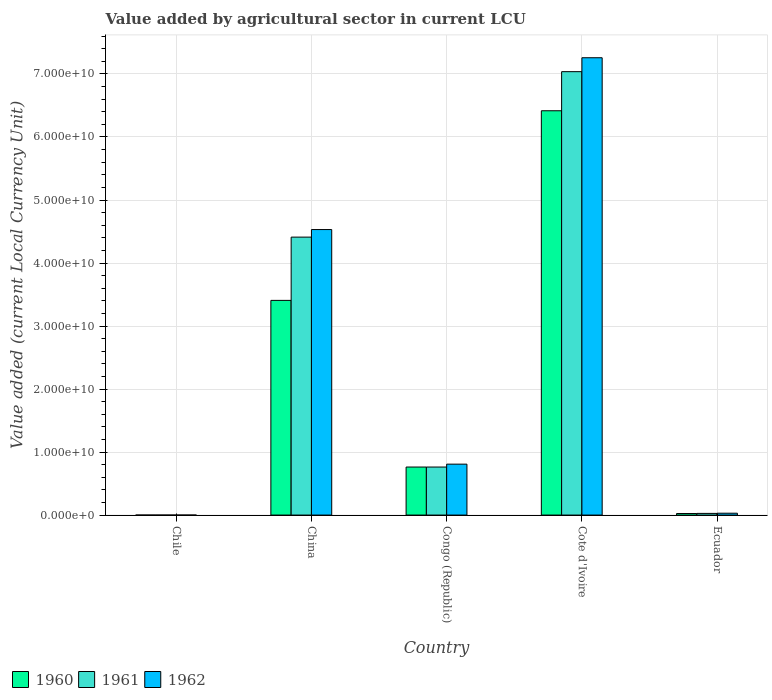How many different coloured bars are there?
Your answer should be compact. 3. How many groups of bars are there?
Provide a succinct answer. 5. How many bars are there on the 2nd tick from the right?
Your response must be concise. 3. What is the label of the 4th group of bars from the left?
Keep it short and to the point. Cote d'Ivoire. In how many cases, is the number of bars for a given country not equal to the number of legend labels?
Give a very brief answer. 0. What is the value added by agricultural sector in 1962 in China?
Your answer should be very brief. 4.53e+1. Across all countries, what is the maximum value added by agricultural sector in 1961?
Ensure brevity in your answer.  7.04e+1. In which country was the value added by agricultural sector in 1962 maximum?
Provide a succinct answer. Cote d'Ivoire. In which country was the value added by agricultural sector in 1962 minimum?
Ensure brevity in your answer.  Chile. What is the total value added by agricultural sector in 1960 in the graph?
Give a very brief answer. 1.06e+11. What is the difference between the value added by agricultural sector in 1960 in Chile and that in China?
Offer a very short reply. -3.41e+1. What is the difference between the value added by agricultural sector in 1962 in Chile and the value added by agricultural sector in 1960 in Congo (Republic)?
Your answer should be very brief. -7.62e+09. What is the average value added by agricultural sector in 1960 per country?
Make the answer very short. 2.12e+1. What is the difference between the value added by agricultural sector of/in 1960 and value added by agricultural sector of/in 1962 in Cote d'Ivoire?
Ensure brevity in your answer.  -8.41e+09. What is the ratio of the value added by agricultural sector in 1962 in Congo (Republic) to that in Ecuador?
Your response must be concise. 27.39. Is the value added by agricultural sector in 1961 in Chile less than that in China?
Give a very brief answer. Yes. Is the difference between the value added by agricultural sector in 1960 in China and Cote d'Ivoire greater than the difference between the value added by agricultural sector in 1962 in China and Cote d'Ivoire?
Provide a succinct answer. No. What is the difference between the highest and the second highest value added by agricultural sector in 1962?
Your answer should be compact. 6.45e+1. What is the difference between the highest and the lowest value added by agricultural sector in 1961?
Keep it short and to the point. 7.04e+1. What does the 3rd bar from the right in Congo (Republic) represents?
Ensure brevity in your answer.  1960. Are all the bars in the graph horizontal?
Offer a very short reply. No. How many countries are there in the graph?
Offer a terse response. 5. What is the difference between two consecutive major ticks on the Y-axis?
Give a very brief answer. 1.00e+1. Does the graph contain grids?
Ensure brevity in your answer.  Yes. How are the legend labels stacked?
Make the answer very short. Horizontal. What is the title of the graph?
Offer a very short reply. Value added by agricultural sector in current LCU. What is the label or title of the X-axis?
Your answer should be compact. Country. What is the label or title of the Y-axis?
Offer a very short reply. Value added (current Local Currency Unit). What is the Value added (current Local Currency Unit) of 1962 in Chile?
Make the answer very short. 5.00e+05. What is the Value added (current Local Currency Unit) of 1960 in China?
Keep it short and to the point. 3.41e+1. What is the Value added (current Local Currency Unit) in 1961 in China?
Provide a succinct answer. 4.41e+1. What is the Value added (current Local Currency Unit) of 1962 in China?
Your response must be concise. 4.53e+1. What is the Value added (current Local Currency Unit) in 1960 in Congo (Republic)?
Offer a terse response. 7.62e+09. What is the Value added (current Local Currency Unit) in 1961 in Congo (Republic)?
Keep it short and to the point. 7.62e+09. What is the Value added (current Local Currency Unit) in 1962 in Congo (Republic)?
Your answer should be compact. 8.08e+09. What is the Value added (current Local Currency Unit) of 1960 in Cote d'Ivoire?
Ensure brevity in your answer.  6.42e+1. What is the Value added (current Local Currency Unit) of 1961 in Cote d'Ivoire?
Make the answer very short. 7.04e+1. What is the Value added (current Local Currency Unit) of 1962 in Cote d'Ivoire?
Your answer should be very brief. 7.26e+1. What is the Value added (current Local Currency Unit) in 1960 in Ecuador?
Provide a short and direct response. 2.45e+08. What is the Value added (current Local Currency Unit) in 1961 in Ecuador?
Your response must be concise. 2.66e+08. What is the Value added (current Local Currency Unit) in 1962 in Ecuador?
Your answer should be compact. 2.95e+08. Across all countries, what is the maximum Value added (current Local Currency Unit) of 1960?
Make the answer very short. 6.42e+1. Across all countries, what is the maximum Value added (current Local Currency Unit) in 1961?
Offer a terse response. 7.04e+1. Across all countries, what is the maximum Value added (current Local Currency Unit) of 1962?
Make the answer very short. 7.26e+1. Across all countries, what is the minimum Value added (current Local Currency Unit) of 1961?
Provide a short and direct response. 5.00e+05. What is the total Value added (current Local Currency Unit) of 1960 in the graph?
Offer a terse response. 1.06e+11. What is the total Value added (current Local Currency Unit) of 1961 in the graph?
Offer a terse response. 1.22e+11. What is the total Value added (current Local Currency Unit) in 1962 in the graph?
Your response must be concise. 1.26e+11. What is the difference between the Value added (current Local Currency Unit) of 1960 in Chile and that in China?
Offer a very short reply. -3.41e+1. What is the difference between the Value added (current Local Currency Unit) in 1961 in Chile and that in China?
Ensure brevity in your answer.  -4.41e+1. What is the difference between the Value added (current Local Currency Unit) of 1962 in Chile and that in China?
Ensure brevity in your answer.  -4.53e+1. What is the difference between the Value added (current Local Currency Unit) in 1960 in Chile and that in Congo (Republic)?
Make the answer very short. -7.62e+09. What is the difference between the Value added (current Local Currency Unit) in 1961 in Chile and that in Congo (Republic)?
Your answer should be compact. -7.62e+09. What is the difference between the Value added (current Local Currency Unit) of 1962 in Chile and that in Congo (Republic)?
Provide a succinct answer. -8.08e+09. What is the difference between the Value added (current Local Currency Unit) in 1960 in Chile and that in Cote d'Ivoire?
Provide a short and direct response. -6.42e+1. What is the difference between the Value added (current Local Currency Unit) of 1961 in Chile and that in Cote d'Ivoire?
Your response must be concise. -7.04e+1. What is the difference between the Value added (current Local Currency Unit) of 1962 in Chile and that in Cote d'Ivoire?
Provide a succinct answer. -7.26e+1. What is the difference between the Value added (current Local Currency Unit) in 1960 in Chile and that in Ecuador?
Give a very brief answer. -2.45e+08. What is the difference between the Value added (current Local Currency Unit) in 1961 in Chile and that in Ecuador?
Ensure brevity in your answer.  -2.66e+08. What is the difference between the Value added (current Local Currency Unit) of 1962 in Chile and that in Ecuador?
Keep it short and to the point. -2.95e+08. What is the difference between the Value added (current Local Currency Unit) of 1960 in China and that in Congo (Republic)?
Make the answer very short. 2.64e+1. What is the difference between the Value added (current Local Currency Unit) of 1961 in China and that in Congo (Republic)?
Your answer should be very brief. 3.65e+1. What is the difference between the Value added (current Local Currency Unit) in 1962 in China and that in Congo (Republic)?
Provide a short and direct response. 3.72e+1. What is the difference between the Value added (current Local Currency Unit) in 1960 in China and that in Cote d'Ivoire?
Make the answer very short. -3.01e+1. What is the difference between the Value added (current Local Currency Unit) of 1961 in China and that in Cote d'Ivoire?
Keep it short and to the point. -2.63e+1. What is the difference between the Value added (current Local Currency Unit) of 1962 in China and that in Cote d'Ivoire?
Give a very brief answer. -2.73e+1. What is the difference between the Value added (current Local Currency Unit) in 1960 in China and that in Ecuador?
Offer a terse response. 3.38e+1. What is the difference between the Value added (current Local Currency Unit) in 1961 in China and that in Ecuador?
Offer a terse response. 4.38e+1. What is the difference between the Value added (current Local Currency Unit) of 1962 in China and that in Ecuador?
Your answer should be compact. 4.50e+1. What is the difference between the Value added (current Local Currency Unit) of 1960 in Congo (Republic) and that in Cote d'Ivoire?
Make the answer very short. -5.65e+1. What is the difference between the Value added (current Local Currency Unit) of 1961 in Congo (Republic) and that in Cote d'Ivoire?
Offer a terse response. -6.27e+1. What is the difference between the Value added (current Local Currency Unit) in 1962 in Congo (Republic) and that in Cote d'Ivoire?
Make the answer very short. -6.45e+1. What is the difference between the Value added (current Local Currency Unit) of 1960 in Congo (Republic) and that in Ecuador?
Your answer should be compact. 7.38e+09. What is the difference between the Value added (current Local Currency Unit) of 1961 in Congo (Republic) and that in Ecuador?
Give a very brief answer. 7.36e+09. What is the difference between the Value added (current Local Currency Unit) of 1962 in Congo (Republic) and that in Ecuador?
Your response must be concise. 7.79e+09. What is the difference between the Value added (current Local Currency Unit) of 1960 in Cote d'Ivoire and that in Ecuador?
Your answer should be compact. 6.39e+1. What is the difference between the Value added (current Local Currency Unit) of 1961 in Cote d'Ivoire and that in Ecuador?
Your answer should be compact. 7.01e+1. What is the difference between the Value added (current Local Currency Unit) in 1962 in Cote d'Ivoire and that in Ecuador?
Offer a very short reply. 7.23e+1. What is the difference between the Value added (current Local Currency Unit) of 1960 in Chile and the Value added (current Local Currency Unit) of 1961 in China?
Keep it short and to the point. -4.41e+1. What is the difference between the Value added (current Local Currency Unit) of 1960 in Chile and the Value added (current Local Currency Unit) of 1962 in China?
Your answer should be very brief. -4.53e+1. What is the difference between the Value added (current Local Currency Unit) of 1961 in Chile and the Value added (current Local Currency Unit) of 1962 in China?
Provide a short and direct response. -4.53e+1. What is the difference between the Value added (current Local Currency Unit) in 1960 in Chile and the Value added (current Local Currency Unit) in 1961 in Congo (Republic)?
Provide a short and direct response. -7.62e+09. What is the difference between the Value added (current Local Currency Unit) in 1960 in Chile and the Value added (current Local Currency Unit) in 1962 in Congo (Republic)?
Your response must be concise. -8.08e+09. What is the difference between the Value added (current Local Currency Unit) in 1961 in Chile and the Value added (current Local Currency Unit) in 1962 in Congo (Republic)?
Offer a very short reply. -8.08e+09. What is the difference between the Value added (current Local Currency Unit) in 1960 in Chile and the Value added (current Local Currency Unit) in 1961 in Cote d'Ivoire?
Offer a very short reply. -7.04e+1. What is the difference between the Value added (current Local Currency Unit) in 1960 in Chile and the Value added (current Local Currency Unit) in 1962 in Cote d'Ivoire?
Offer a terse response. -7.26e+1. What is the difference between the Value added (current Local Currency Unit) in 1961 in Chile and the Value added (current Local Currency Unit) in 1962 in Cote d'Ivoire?
Ensure brevity in your answer.  -7.26e+1. What is the difference between the Value added (current Local Currency Unit) in 1960 in Chile and the Value added (current Local Currency Unit) in 1961 in Ecuador?
Ensure brevity in your answer.  -2.66e+08. What is the difference between the Value added (current Local Currency Unit) of 1960 in Chile and the Value added (current Local Currency Unit) of 1962 in Ecuador?
Your response must be concise. -2.95e+08. What is the difference between the Value added (current Local Currency Unit) in 1961 in Chile and the Value added (current Local Currency Unit) in 1962 in Ecuador?
Provide a short and direct response. -2.95e+08. What is the difference between the Value added (current Local Currency Unit) in 1960 in China and the Value added (current Local Currency Unit) in 1961 in Congo (Republic)?
Ensure brevity in your answer.  2.64e+1. What is the difference between the Value added (current Local Currency Unit) in 1960 in China and the Value added (current Local Currency Unit) in 1962 in Congo (Republic)?
Ensure brevity in your answer.  2.60e+1. What is the difference between the Value added (current Local Currency Unit) in 1961 in China and the Value added (current Local Currency Unit) in 1962 in Congo (Republic)?
Make the answer very short. 3.60e+1. What is the difference between the Value added (current Local Currency Unit) in 1960 in China and the Value added (current Local Currency Unit) in 1961 in Cote d'Ivoire?
Offer a very short reply. -3.63e+1. What is the difference between the Value added (current Local Currency Unit) in 1960 in China and the Value added (current Local Currency Unit) in 1962 in Cote d'Ivoire?
Keep it short and to the point. -3.85e+1. What is the difference between the Value added (current Local Currency Unit) of 1961 in China and the Value added (current Local Currency Unit) of 1962 in Cote d'Ivoire?
Give a very brief answer. -2.85e+1. What is the difference between the Value added (current Local Currency Unit) in 1960 in China and the Value added (current Local Currency Unit) in 1961 in Ecuador?
Keep it short and to the point. 3.38e+1. What is the difference between the Value added (current Local Currency Unit) of 1960 in China and the Value added (current Local Currency Unit) of 1962 in Ecuador?
Give a very brief answer. 3.38e+1. What is the difference between the Value added (current Local Currency Unit) in 1961 in China and the Value added (current Local Currency Unit) in 1962 in Ecuador?
Provide a short and direct response. 4.38e+1. What is the difference between the Value added (current Local Currency Unit) of 1960 in Congo (Republic) and the Value added (current Local Currency Unit) of 1961 in Cote d'Ivoire?
Give a very brief answer. -6.27e+1. What is the difference between the Value added (current Local Currency Unit) of 1960 in Congo (Republic) and the Value added (current Local Currency Unit) of 1962 in Cote d'Ivoire?
Provide a short and direct response. -6.50e+1. What is the difference between the Value added (current Local Currency Unit) in 1961 in Congo (Republic) and the Value added (current Local Currency Unit) in 1962 in Cote d'Ivoire?
Your response must be concise. -6.50e+1. What is the difference between the Value added (current Local Currency Unit) in 1960 in Congo (Republic) and the Value added (current Local Currency Unit) in 1961 in Ecuador?
Keep it short and to the point. 7.36e+09. What is the difference between the Value added (current Local Currency Unit) in 1960 in Congo (Republic) and the Value added (current Local Currency Unit) in 1962 in Ecuador?
Offer a very short reply. 7.33e+09. What is the difference between the Value added (current Local Currency Unit) of 1961 in Congo (Republic) and the Value added (current Local Currency Unit) of 1962 in Ecuador?
Provide a succinct answer. 7.33e+09. What is the difference between the Value added (current Local Currency Unit) in 1960 in Cote d'Ivoire and the Value added (current Local Currency Unit) in 1961 in Ecuador?
Your answer should be compact. 6.39e+1. What is the difference between the Value added (current Local Currency Unit) of 1960 in Cote d'Ivoire and the Value added (current Local Currency Unit) of 1962 in Ecuador?
Provide a succinct answer. 6.39e+1. What is the difference between the Value added (current Local Currency Unit) in 1961 in Cote d'Ivoire and the Value added (current Local Currency Unit) in 1962 in Ecuador?
Make the answer very short. 7.01e+1. What is the average Value added (current Local Currency Unit) in 1960 per country?
Give a very brief answer. 2.12e+1. What is the average Value added (current Local Currency Unit) in 1961 per country?
Your response must be concise. 2.45e+1. What is the average Value added (current Local Currency Unit) in 1962 per country?
Your answer should be compact. 2.53e+1. What is the difference between the Value added (current Local Currency Unit) in 1960 and Value added (current Local Currency Unit) in 1961 in Chile?
Provide a succinct answer. -1.00e+05. What is the difference between the Value added (current Local Currency Unit) of 1960 and Value added (current Local Currency Unit) of 1962 in Chile?
Provide a succinct answer. -1.00e+05. What is the difference between the Value added (current Local Currency Unit) in 1961 and Value added (current Local Currency Unit) in 1962 in Chile?
Give a very brief answer. 0. What is the difference between the Value added (current Local Currency Unit) of 1960 and Value added (current Local Currency Unit) of 1961 in China?
Your answer should be compact. -1.00e+1. What is the difference between the Value added (current Local Currency Unit) in 1960 and Value added (current Local Currency Unit) in 1962 in China?
Offer a terse response. -1.12e+1. What is the difference between the Value added (current Local Currency Unit) of 1961 and Value added (current Local Currency Unit) of 1962 in China?
Ensure brevity in your answer.  -1.20e+09. What is the difference between the Value added (current Local Currency Unit) of 1960 and Value added (current Local Currency Unit) of 1961 in Congo (Republic)?
Your response must be concise. 0. What is the difference between the Value added (current Local Currency Unit) of 1960 and Value added (current Local Currency Unit) of 1962 in Congo (Republic)?
Keep it short and to the point. -4.57e+08. What is the difference between the Value added (current Local Currency Unit) of 1961 and Value added (current Local Currency Unit) of 1962 in Congo (Republic)?
Give a very brief answer. -4.57e+08. What is the difference between the Value added (current Local Currency Unit) of 1960 and Value added (current Local Currency Unit) of 1961 in Cote d'Ivoire?
Your answer should be very brief. -6.21e+09. What is the difference between the Value added (current Local Currency Unit) in 1960 and Value added (current Local Currency Unit) in 1962 in Cote d'Ivoire?
Provide a succinct answer. -8.41e+09. What is the difference between the Value added (current Local Currency Unit) in 1961 and Value added (current Local Currency Unit) in 1962 in Cote d'Ivoire?
Give a very brief answer. -2.21e+09. What is the difference between the Value added (current Local Currency Unit) of 1960 and Value added (current Local Currency Unit) of 1961 in Ecuador?
Offer a very short reply. -2.09e+07. What is the difference between the Value added (current Local Currency Unit) in 1960 and Value added (current Local Currency Unit) in 1962 in Ecuador?
Ensure brevity in your answer.  -4.98e+07. What is the difference between the Value added (current Local Currency Unit) in 1961 and Value added (current Local Currency Unit) in 1962 in Ecuador?
Give a very brief answer. -2.89e+07. What is the ratio of the Value added (current Local Currency Unit) in 1961 in Chile to that in Congo (Republic)?
Offer a terse response. 0. What is the ratio of the Value added (current Local Currency Unit) of 1960 in Chile to that in Cote d'Ivoire?
Keep it short and to the point. 0. What is the ratio of the Value added (current Local Currency Unit) of 1960 in Chile to that in Ecuador?
Your response must be concise. 0. What is the ratio of the Value added (current Local Currency Unit) of 1961 in Chile to that in Ecuador?
Keep it short and to the point. 0. What is the ratio of the Value added (current Local Currency Unit) in 1962 in Chile to that in Ecuador?
Offer a very short reply. 0. What is the ratio of the Value added (current Local Currency Unit) of 1960 in China to that in Congo (Republic)?
Give a very brief answer. 4.47. What is the ratio of the Value added (current Local Currency Unit) of 1961 in China to that in Congo (Republic)?
Provide a succinct answer. 5.79. What is the ratio of the Value added (current Local Currency Unit) of 1962 in China to that in Congo (Republic)?
Ensure brevity in your answer.  5.61. What is the ratio of the Value added (current Local Currency Unit) in 1960 in China to that in Cote d'Ivoire?
Ensure brevity in your answer.  0.53. What is the ratio of the Value added (current Local Currency Unit) of 1961 in China to that in Cote d'Ivoire?
Give a very brief answer. 0.63. What is the ratio of the Value added (current Local Currency Unit) in 1962 in China to that in Cote d'Ivoire?
Your answer should be very brief. 0.62. What is the ratio of the Value added (current Local Currency Unit) in 1960 in China to that in Ecuador?
Provide a short and direct response. 138.9. What is the ratio of the Value added (current Local Currency Unit) in 1961 in China to that in Ecuador?
Your answer should be compact. 165.71. What is the ratio of the Value added (current Local Currency Unit) in 1962 in China to that in Ecuador?
Keep it short and to the point. 153.57. What is the ratio of the Value added (current Local Currency Unit) of 1960 in Congo (Republic) to that in Cote d'Ivoire?
Make the answer very short. 0.12. What is the ratio of the Value added (current Local Currency Unit) of 1961 in Congo (Republic) to that in Cote d'Ivoire?
Offer a terse response. 0.11. What is the ratio of the Value added (current Local Currency Unit) of 1962 in Congo (Republic) to that in Cote d'Ivoire?
Ensure brevity in your answer.  0.11. What is the ratio of the Value added (current Local Currency Unit) of 1960 in Congo (Republic) to that in Ecuador?
Give a very brief answer. 31.08. What is the ratio of the Value added (current Local Currency Unit) of 1961 in Congo (Republic) to that in Ecuador?
Provide a short and direct response. 28.64. What is the ratio of the Value added (current Local Currency Unit) of 1962 in Congo (Republic) to that in Ecuador?
Give a very brief answer. 27.39. What is the ratio of the Value added (current Local Currency Unit) in 1960 in Cote d'Ivoire to that in Ecuador?
Keep it short and to the point. 261.58. What is the ratio of the Value added (current Local Currency Unit) in 1961 in Cote d'Ivoire to that in Ecuador?
Keep it short and to the point. 264.35. What is the ratio of the Value added (current Local Currency Unit) of 1962 in Cote d'Ivoire to that in Ecuador?
Provide a short and direct response. 245.99. What is the difference between the highest and the second highest Value added (current Local Currency Unit) in 1960?
Provide a short and direct response. 3.01e+1. What is the difference between the highest and the second highest Value added (current Local Currency Unit) of 1961?
Provide a succinct answer. 2.63e+1. What is the difference between the highest and the second highest Value added (current Local Currency Unit) of 1962?
Ensure brevity in your answer.  2.73e+1. What is the difference between the highest and the lowest Value added (current Local Currency Unit) in 1960?
Your answer should be compact. 6.42e+1. What is the difference between the highest and the lowest Value added (current Local Currency Unit) of 1961?
Ensure brevity in your answer.  7.04e+1. What is the difference between the highest and the lowest Value added (current Local Currency Unit) of 1962?
Ensure brevity in your answer.  7.26e+1. 